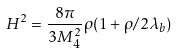<formula> <loc_0><loc_0><loc_500><loc_500>H ^ { 2 } = \frac { 8 \pi } { 3 M _ { 4 } ^ { 2 } } \rho ( 1 + \rho / 2 \lambda _ { b } )</formula> 